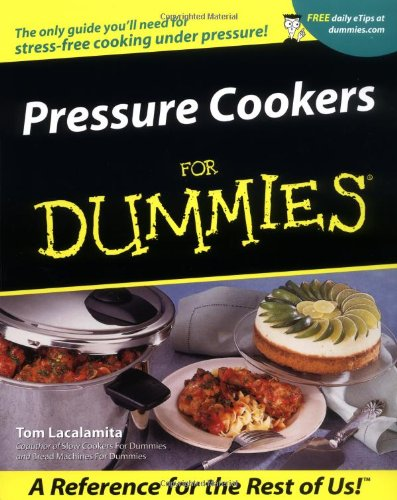What type of book is this? This book belongs to the 'Cookbooks, Food & Wine' category, specifically focusing on how to use pressure cookers for cooking various dishes. 